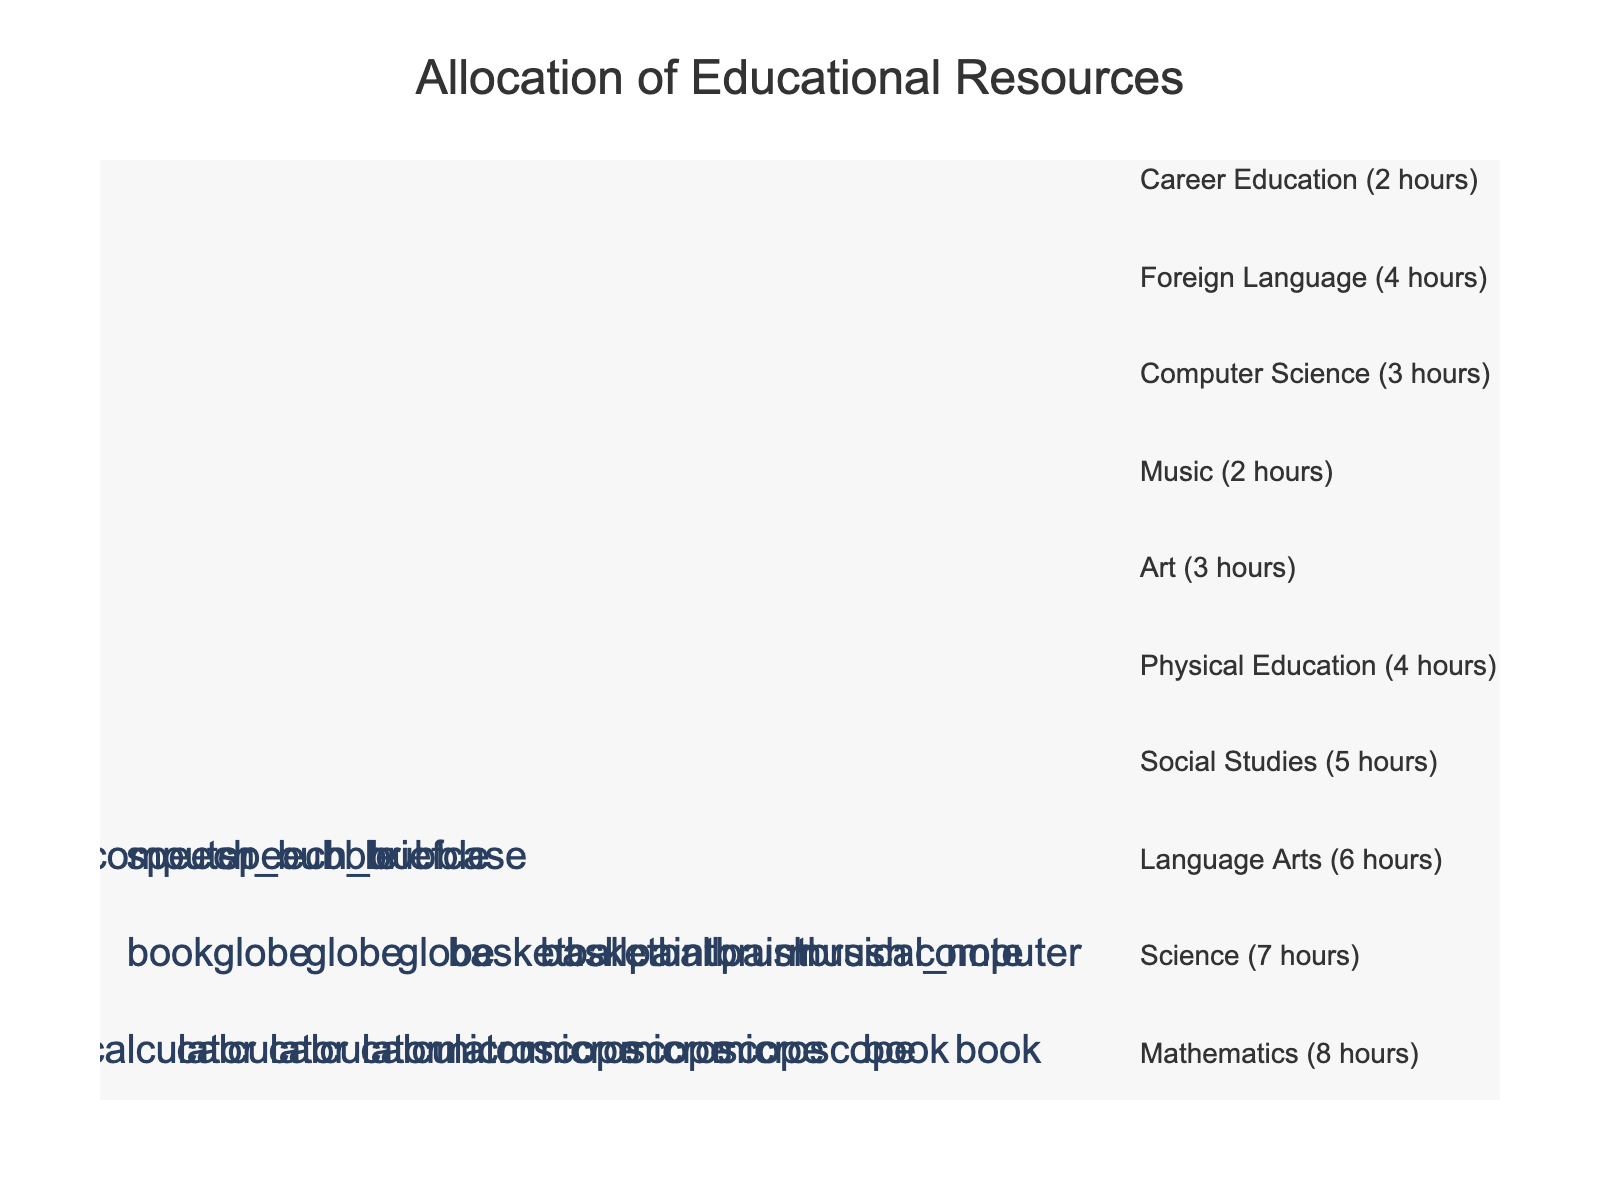How many hours per week are allocated to Mathematics? The figure indicates that Mathematics is represented by icons of a calculator. By counting the text labels or adjacent annotations, we see that Mathematics is given 8 hours.
Answer: 8 Which subject has the fewest hours allocated, and how many hours is it given? By examining the annotations, we can see that Music and Career Education both have the smallest number of hours allocated, each being given 2 hours.
Answer: Music and Career Education, 2 hours What is the total number of hours allocated to subjects related to arts (Art and Music)? The figure shows that Art is allocated 3 hours, and Music is allocated 2 hours. Adding these together gives 3 + 2 = 5 hours.
Answer: 5 hours Which subject receives more hours, Social Studies or Language Arts, and by how many hours? According to the figure, Social Studies is allocated 5 hours, and Language Arts is allocated 6 hours. The difference in allocation is 6 - 5 = 1 hour.
Answer: Language Arts, by 1 hour How many subjects have 4 hours allocated? The figure reveals that Physical Education and Foreign Language each have 4 hours allocated.
Answer: 2 subjects What is the sum of hours allocated to Science and Computer Science? Science is allocated 7 hours, and Computer Science is allocated 3 hours. Adding these together gives 7 + 3 = 10 hours.
Answer: 10 hours Which subject is represented by a computer icon, and how many hours is it allocated? By checking the icons and text labels, we see that Computer Science is represented by a computer icon and is allocated 3 hours.
Answer: Computer Science, 3 hours What is the average number of hours allocated per subject across all listed subjects? To find the average, sum the hours for all subjects: 8 + 7 + 6 + 5 + 4 + 3 + 2 + 3 + 4 + 2 = 44 hours. There are 10 subjects, so the average is 44 / 10 = 4.4 hours.
Answer: 4.4 hours 